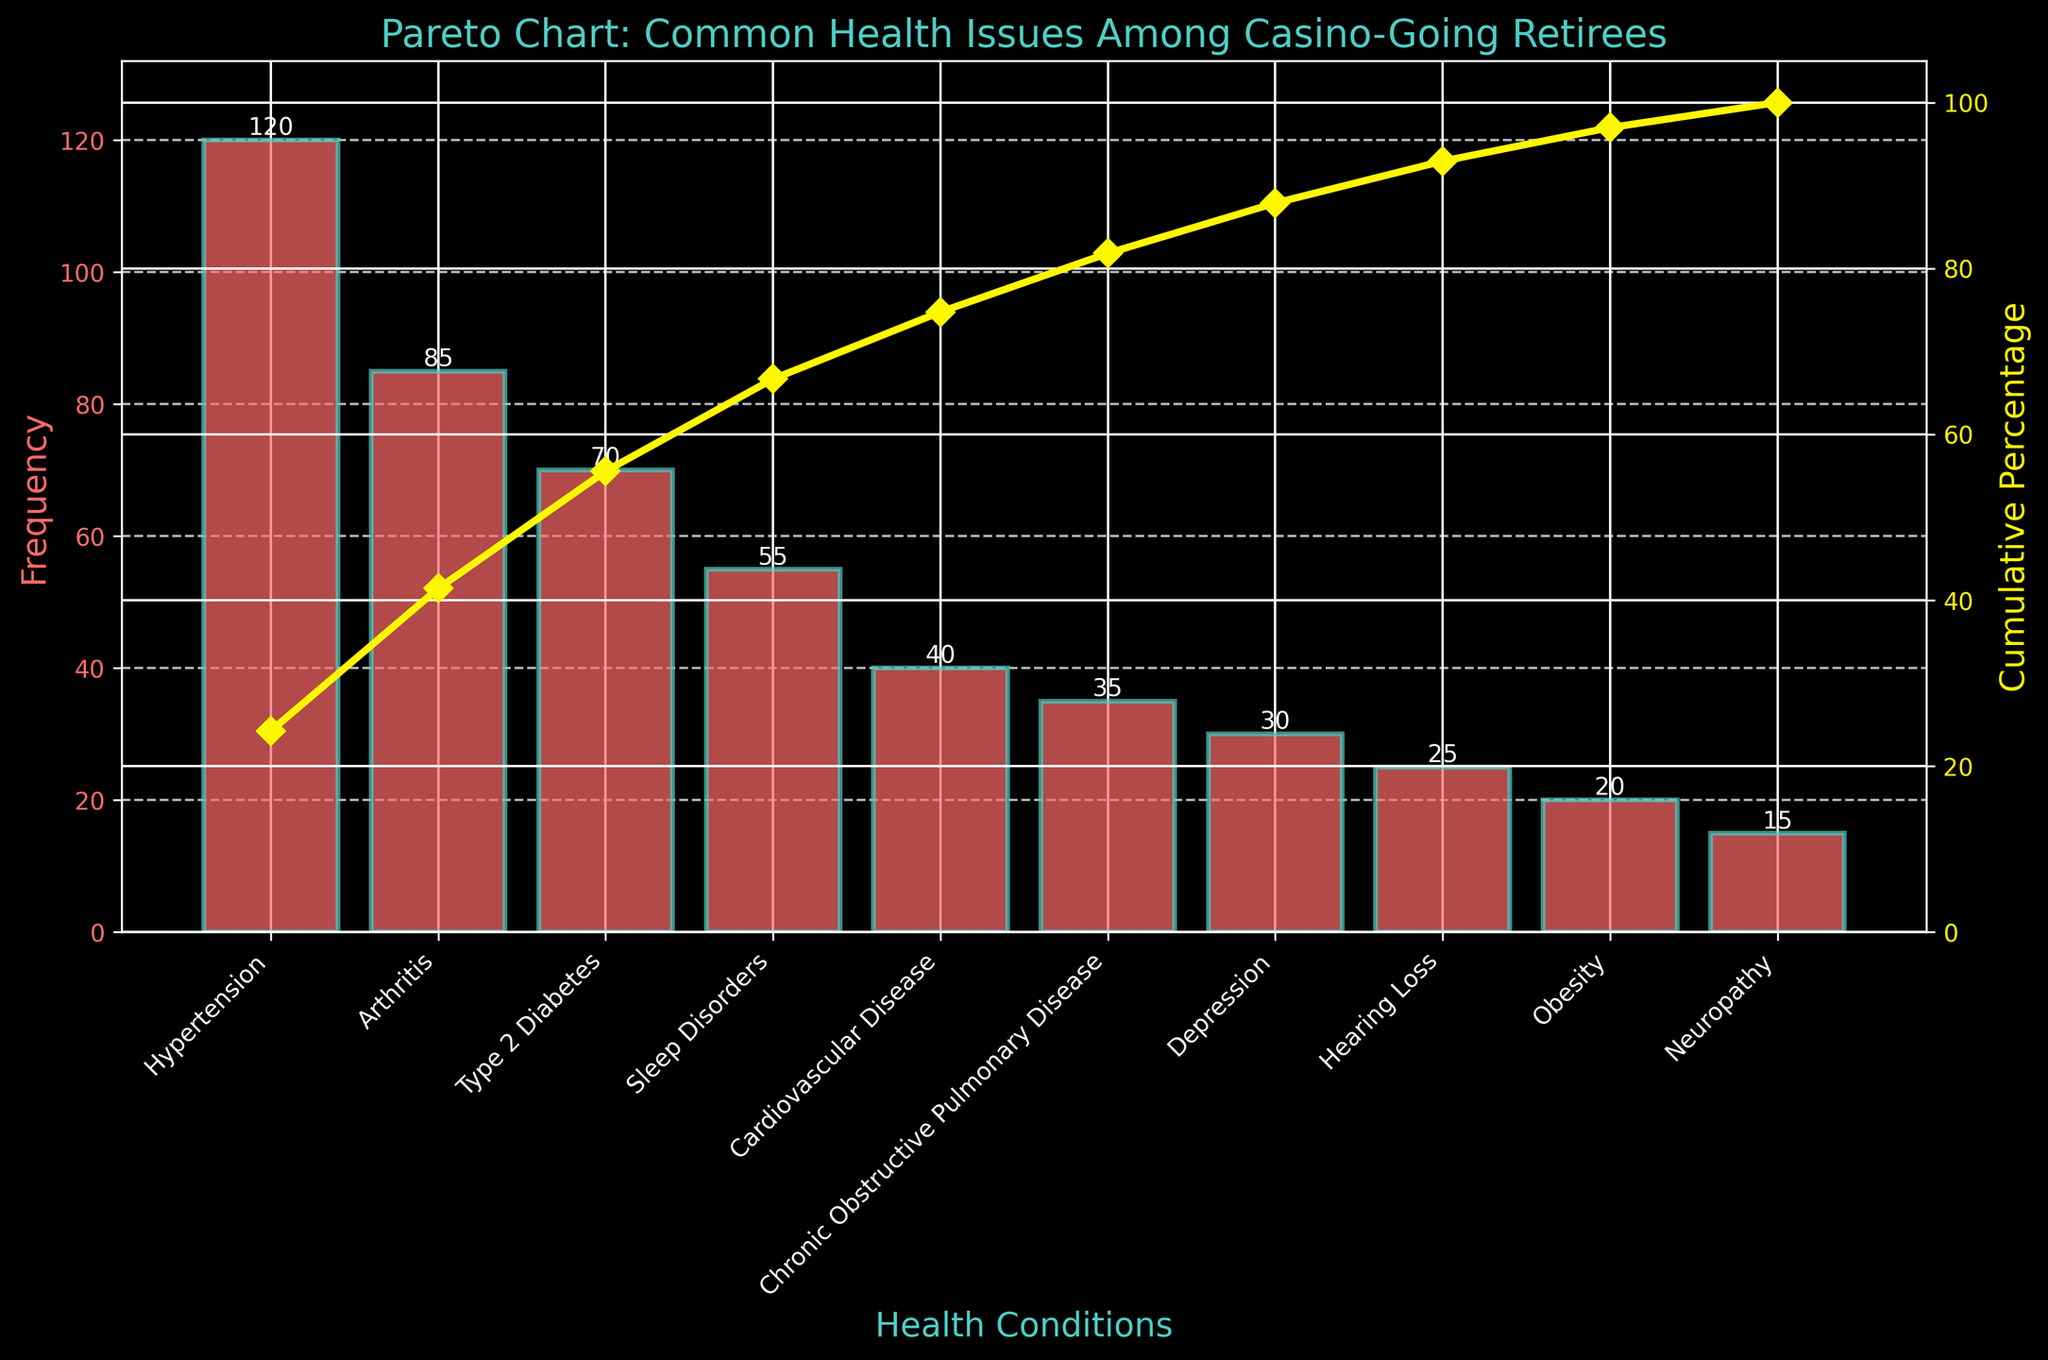What is the most common health condition among casino-going retirees? The bar with the highest frequency represents the most common health condition. The condition with the highest bar is Hypertension, with a frequency of 120.
Answer: Hypertension What is the cumulative percentage for the top two conditions? Combine the frequencies of the top two conditions: Hypertension (120) and Arthritis (85). The total frequency for these is 120 + 85 = 205. The cumulative percentage for these is (205 / (total frequency)) * 100%. Summing up all frequencies gives 495. Therefore, cumulative percentage = (205/495) * 100 ≈ 41.41%.
Answer: 41.41% Which health condition has a frequency of 35? Locate the bar with a height of 35. This corresponds to the Chronic Obstructive Pulmonary Disease condition.
Answer: Chronic Obstructive Pulmonary Disease What is the cumulative percentage after adding Type 2 Diabetes? Add the frequency of Type 2 Diabetes (70) to the cumulative frequency of the earlier conditions (Hypertension and Arthritis: 205). The total becomes 205 + 70 = 275. Calculate cumulative percentage: (275 / 495) * 100 ≈ 55.56%.
Answer: 55.56% How many health conditions have a frequency greater than or equal to 50? Look for bars that reach 50 or higher. The conditions are Hypertension, Arthritis, Type 2 Diabetes, and Sleep Disorders, making a total of 4.
Answer: 4 Which condition is associated with the smallest segment in the Pareto chart? The condition with the smallest bar is the one with the lowest frequency. Neuropathy has the smallest frequency (15).
Answer: Neuropathy How does the frequency of Cardiovascular Disease compare to that of Arthritis? Compare the heights of the bars for both conditions. Arthritis has a frequency of 85, and Cardiovascular Disease has 40. Arthritis has a higher frequency than Cardiovascular Disease.
Answer: Arthritis has a higher frequency What's the cumulative percentage just before adding Hearing Loss? Add the frequencies of conditions before Hearing Loss: Hypertension (120), Arthritis (85), Type 2 Diabetes (70), Sleep Disorders (55), Cardiovascular Disease (40), and Chronic Obstructive Pulmonary Disease (35). The total is 405. The cumulative percentage is (405 / 495) * 100 ≈ 81.82%.
Answer: 81.82% 